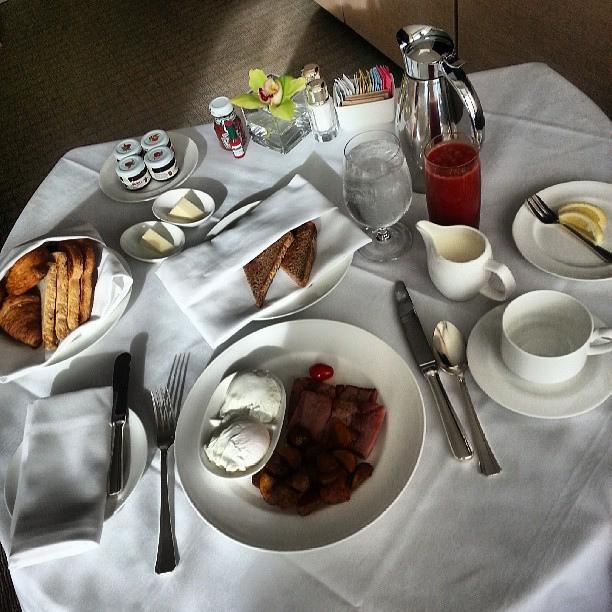Is there any marmalade on the table?
Quick response, please. Yes. Is this in a house?
Answer briefly. No. What kind of flower is on the table?
Answer briefly. Rose. How many place settings?
Answer briefly. 1. 